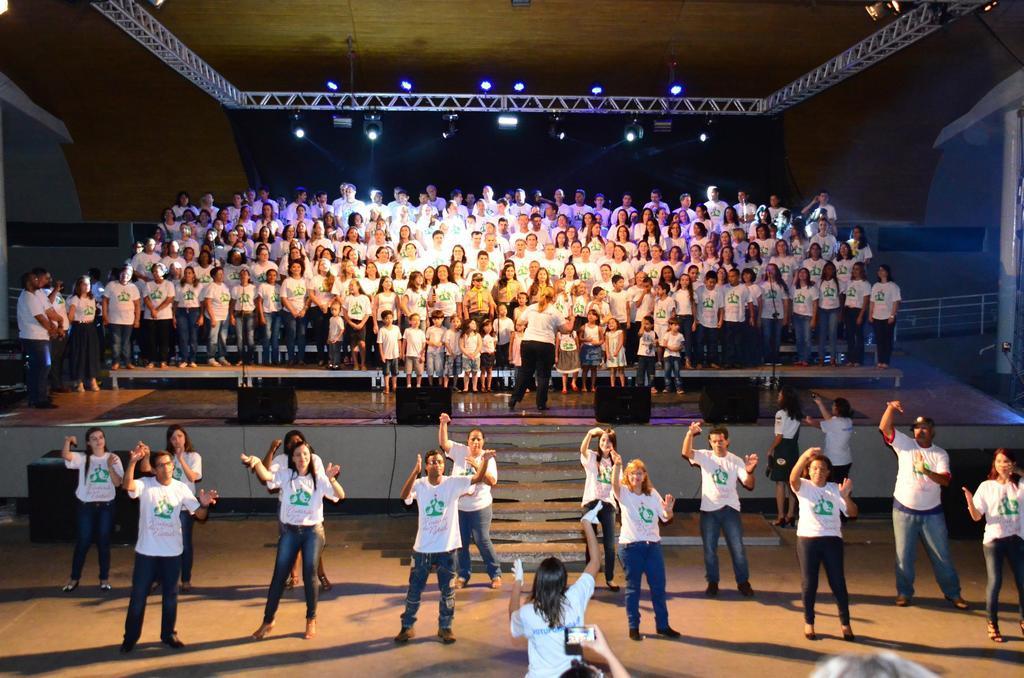How would you summarize this image in a sentence or two? Here we can see group of people standing on the stage and there are few persons dancing on the floor. In the background we can see lights and a pole. 